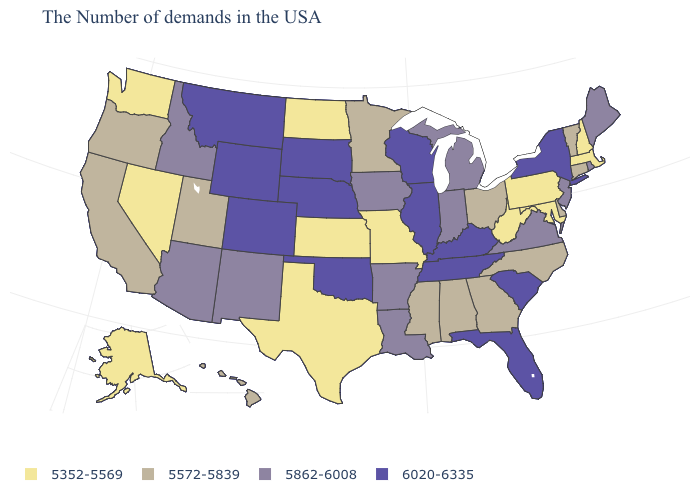What is the lowest value in the Northeast?
Concise answer only. 5352-5569. How many symbols are there in the legend?
Write a very short answer. 4. Does Wyoming have the highest value in the USA?
Quick response, please. Yes. What is the value of Delaware?
Short answer required. 5572-5839. Which states have the lowest value in the USA?
Give a very brief answer. Massachusetts, New Hampshire, Maryland, Pennsylvania, West Virginia, Missouri, Kansas, Texas, North Dakota, Nevada, Washington, Alaska. Does the first symbol in the legend represent the smallest category?
Short answer required. Yes. Does the map have missing data?
Concise answer only. No. Does the map have missing data?
Be succinct. No. What is the value of Michigan?
Keep it brief. 5862-6008. What is the highest value in states that border New Hampshire?
Short answer required. 5862-6008. What is the value of Missouri?
Concise answer only. 5352-5569. Which states have the lowest value in the Northeast?
Short answer required. Massachusetts, New Hampshire, Pennsylvania. Name the states that have a value in the range 5862-6008?
Quick response, please. Maine, Rhode Island, New Jersey, Virginia, Michigan, Indiana, Louisiana, Arkansas, Iowa, New Mexico, Arizona, Idaho. Name the states that have a value in the range 5352-5569?
Short answer required. Massachusetts, New Hampshire, Maryland, Pennsylvania, West Virginia, Missouri, Kansas, Texas, North Dakota, Nevada, Washington, Alaska. What is the value of Kansas?
Answer briefly. 5352-5569. 